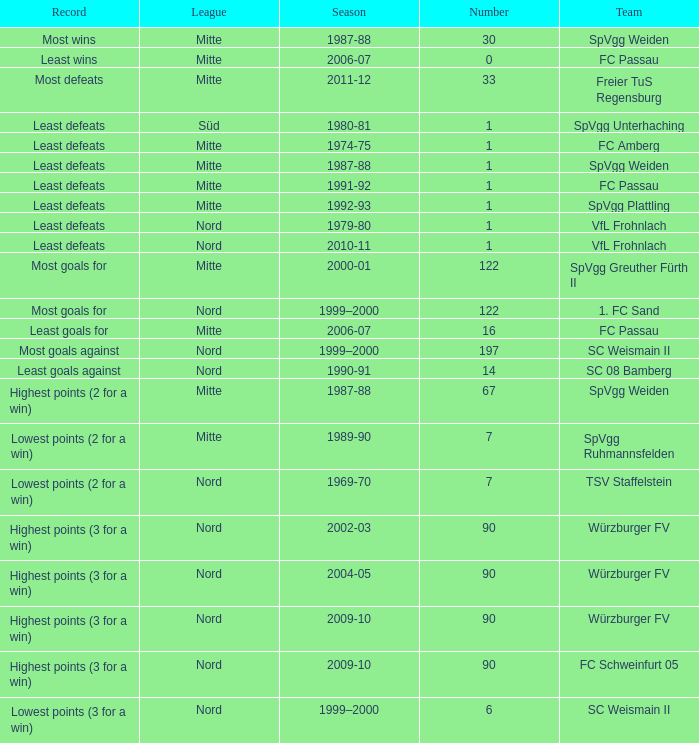What league has a number less than 1? Mitte. 